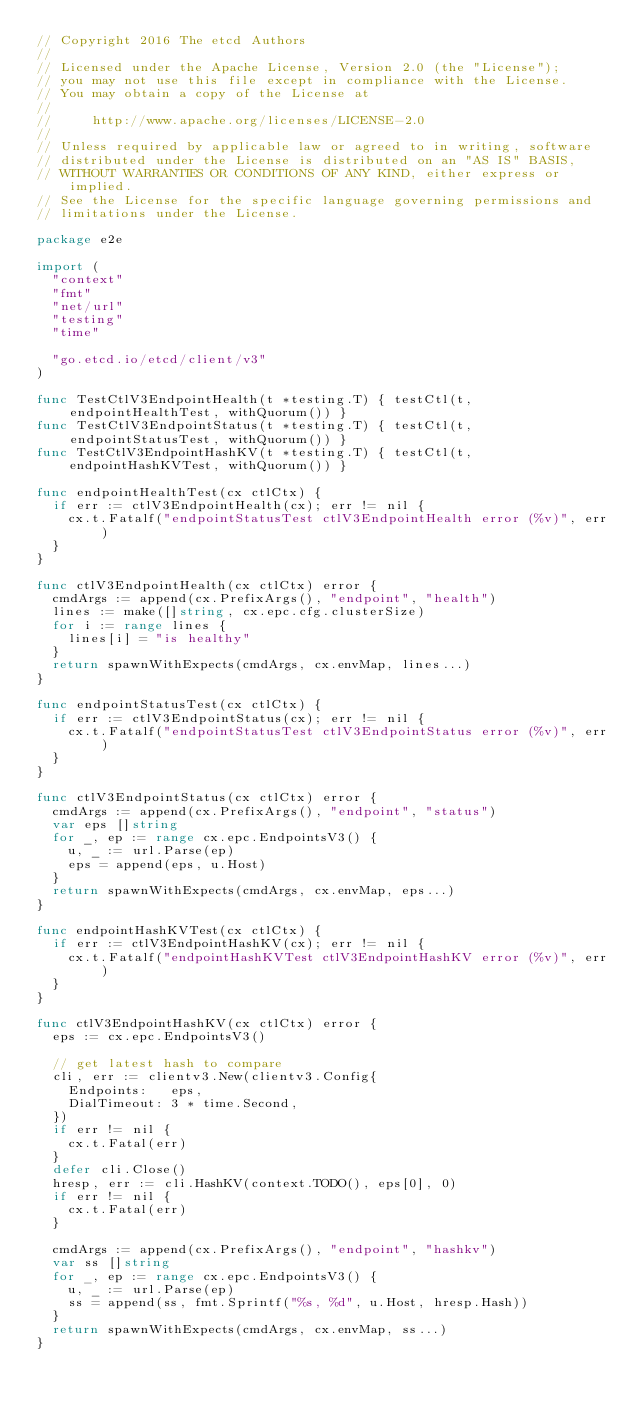<code> <loc_0><loc_0><loc_500><loc_500><_Go_>// Copyright 2016 The etcd Authors
//
// Licensed under the Apache License, Version 2.0 (the "License");
// you may not use this file except in compliance with the License.
// You may obtain a copy of the License at
//
//     http://www.apache.org/licenses/LICENSE-2.0
//
// Unless required by applicable law or agreed to in writing, software
// distributed under the License is distributed on an "AS IS" BASIS,
// WITHOUT WARRANTIES OR CONDITIONS OF ANY KIND, either express or implied.
// See the License for the specific language governing permissions and
// limitations under the License.

package e2e

import (
	"context"
	"fmt"
	"net/url"
	"testing"
	"time"

	"go.etcd.io/etcd/client/v3"
)

func TestCtlV3EndpointHealth(t *testing.T) { testCtl(t, endpointHealthTest, withQuorum()) }
func TestCtlV3EndpointStatus(t *testing.T) { testCtl(t, endpointStatusTest, withQuorum()) }
func TestCtlV3EndpointHashKV(t *testing.T) { testCtl(t, endpointHashKVTest, withQuorum()) }

func endpointHealthTest(cx ctlCtx) {
	if err := ctlV3EndpointHealth(cx); err != nil {
		cx.t.Fatalf("endpointStatusTest ctlV3EndpointHealth error (%v)", err)
	}
}

func ctlV3EndpointHealth(cx ctlCtx) error {
	cmdArgs := append(cx.PrefixArgs(), "endpoint", "health")
	lines := make([]string, cx.epc.cfg.clusterSize)
	for i := range lines {
		lines[i] = "is healthy"
	}
	return spawnWithExpects(cmdArgs, cx.envMap, lines...)
}

func endpointStatusTest(cx ctlCtx) {
	if err := ctlV3EndpointStatus(cx); err != nil {
		cx.t.Fatalf("endpointStatusTest ctlV3EndpointStatus error (%v)", err)
	}
}

func ctlV3EndpointStatus(cx ctlCtx) error {
	cmdArgs := append(cx.PrefixArgs(), "endpoint", "status")
	var eps []string
	for _, ep := range cx.epc.EndpointsV3() {
		u, _ := url.Parse(ep)
		eps = append(eps, u.Host)
	}
	return spawnWithExpects(cmdArgs, cx.envMap, eps...)
}

func endpointHashKVTest(cx ctlCtx) {
	if err := ctlV3EndpointHashKV(cx); err != nil {
		cx.t.Fatalf("endpointHashKVTest ctlV3EndpointHashKV error (%v)", err)
	}
}

func ctlV3EndpointHashKV(cx ctlCtx) error {
	eps := cx.epc.EndpointsV3()

	// get latest hash to compare
	cli, err := clientv3.New(clientv3.Config{
		Endpoints:   eps,
		DialTimeout: 3 * time.Second,
	})
	if err != nil {
		cx.t.Fatal(err)
	}
	defer cli.Close()
	hresp, err := cli.HashKV(context.TODO(), eps[0], 0)
	if err != nil {
		cx.t.Fatal(err)
	}

	cmdArgs := append(cx.PrefixArgs(), "endpoint", "hashkv")
	var ss []string
	for _, ep := range cx.epc.EndpointsV3() {
		u, _ := url.Parse(ep)
		ss = append(ss, fmt.Sprintf("%s, %d", u.Host, hresp.Hash))
	}
	return spawnWithExpects(cmdArgs, cx.envMap, ss...)
}
</code> 